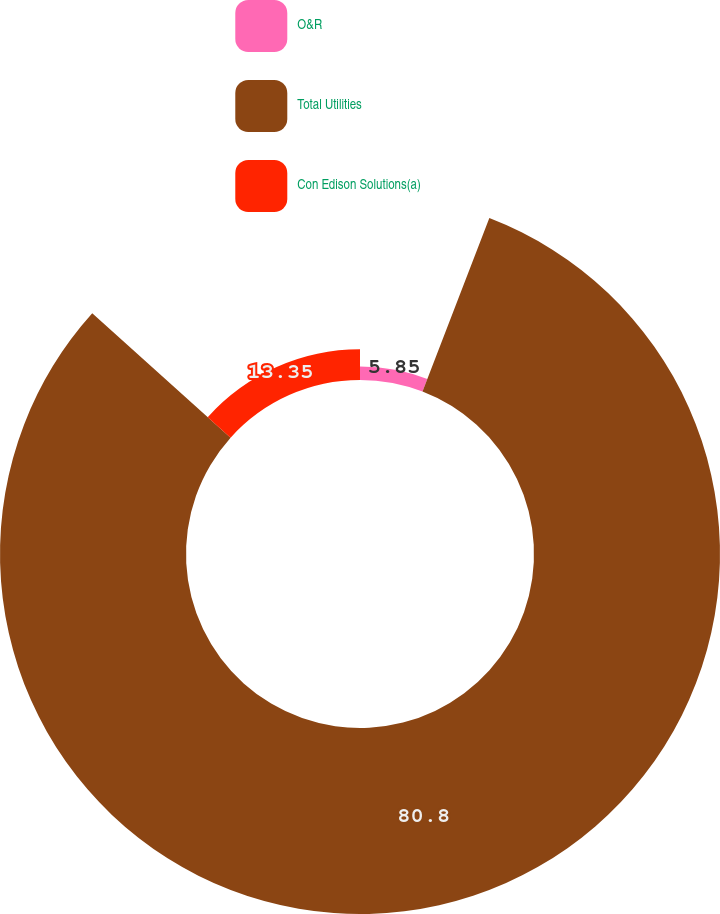Convert chart. <chart><loc_0><loc_0><loc_500><loc_500><pie_chart><fcel>O&R<fcel>Total Utilities<fcel>Con Edison Solutions(a)<nl><fcel>5.85%<fcel>80.81%<fcel>13.35%<nl></chart> 